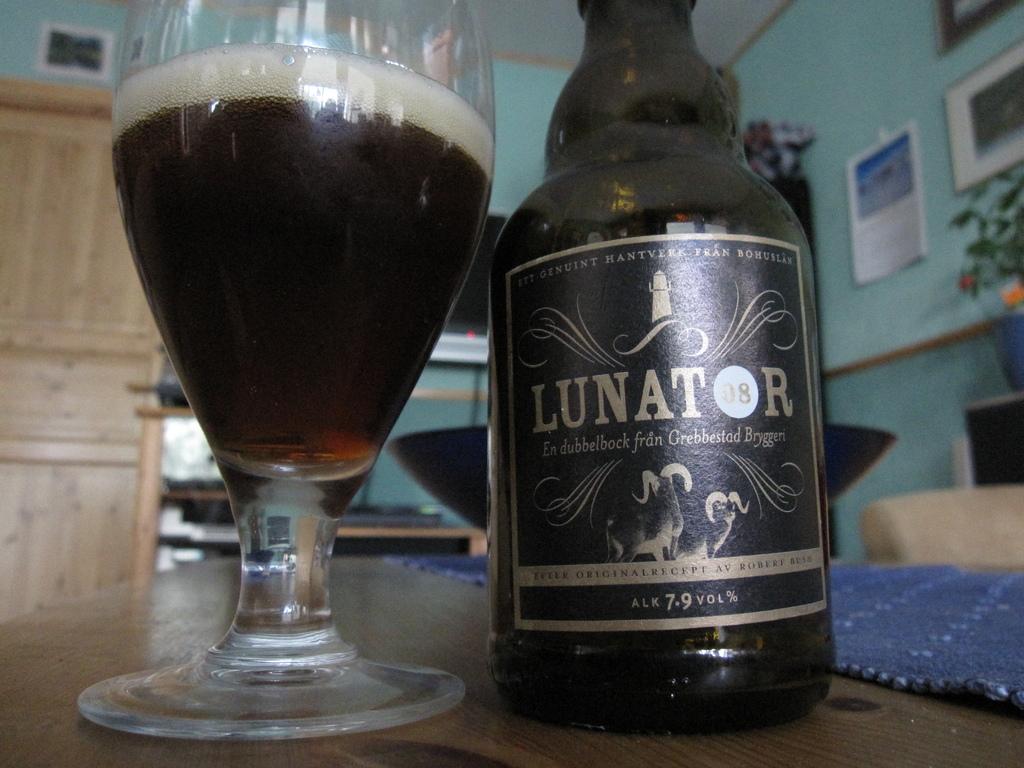What percent of alcohol is in this?
Give a very brief answer. 7.9%. What type of drink is that?
Your answer should be very brief. Lunator. 